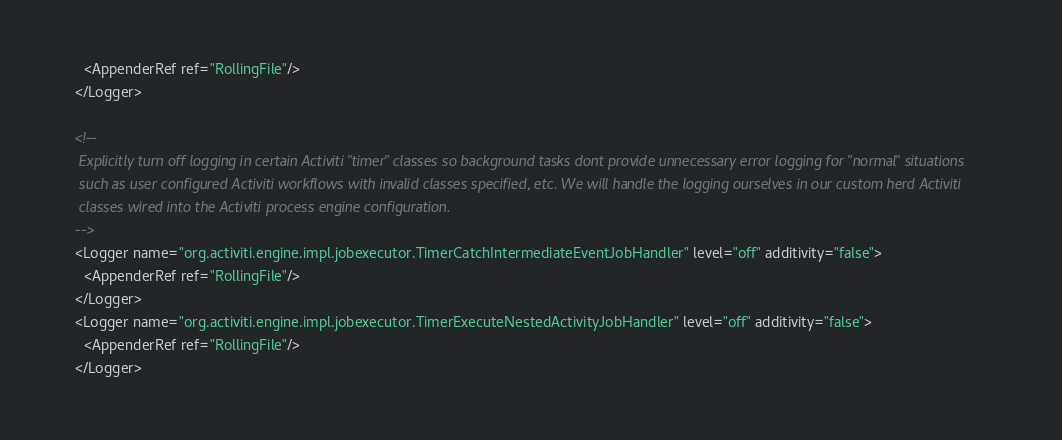Convert code to text. <code><loc_0><loc_0><loc_500><loc_500><_XML_>      <AppenderRef ref="RollingFile"/>
    </Logger>

    <!--
     Explicitly turn off logging in certain Activiti "timer" classes so background tasks dont provide unnecessary error logging for "normal" situations
     such as user configured Activiti workflows with invalid classes specified, etc. We will handle the logging ourselves in our custom herd Activiti
     classes wired into the Activiti process engine configuration.
    -->
    <Logger name="org.activiti.engine.impl.jobexecutor.TimerCatchIntermediateEventJobHandler" level="off" additivity="false">
      <AppenderRef ref="RollingFile"/>
    </Logger>
    <Logger name="org.activiti.engine.impl.jobexecutor.TimerExecuteNestedActivityJobHandler" level="off" additivity="false">
      <AppenderRef ref="RollingFile"/>
    </Logger></code> 